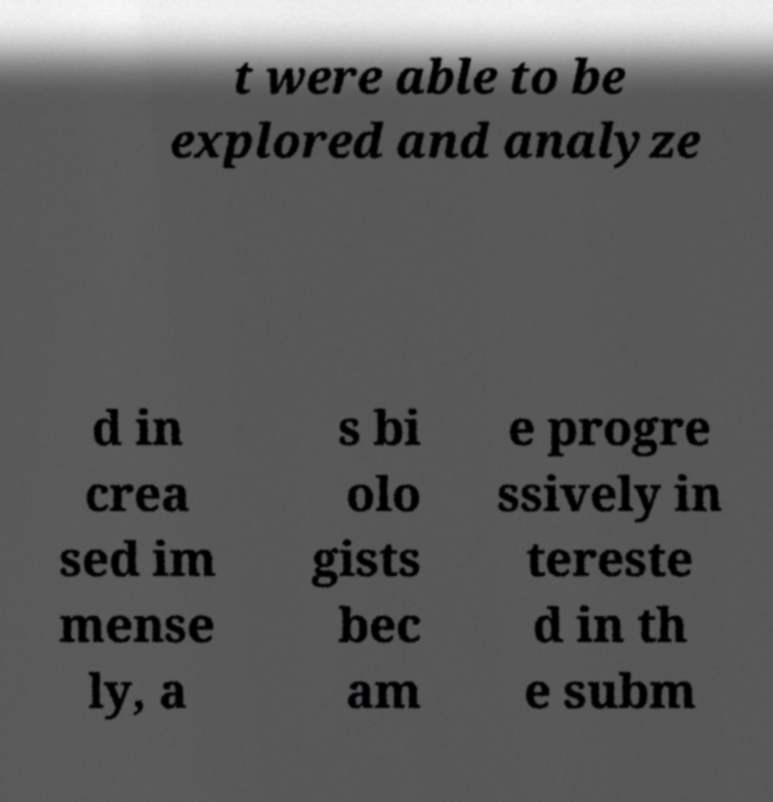For documentation purposes, I need the text within this image transcribed. Could you provide that? t were able to be explored and analyze d in crea sed im mense ly, a s bi olo gists bec am e progre ssively in tereste d in th e subm 